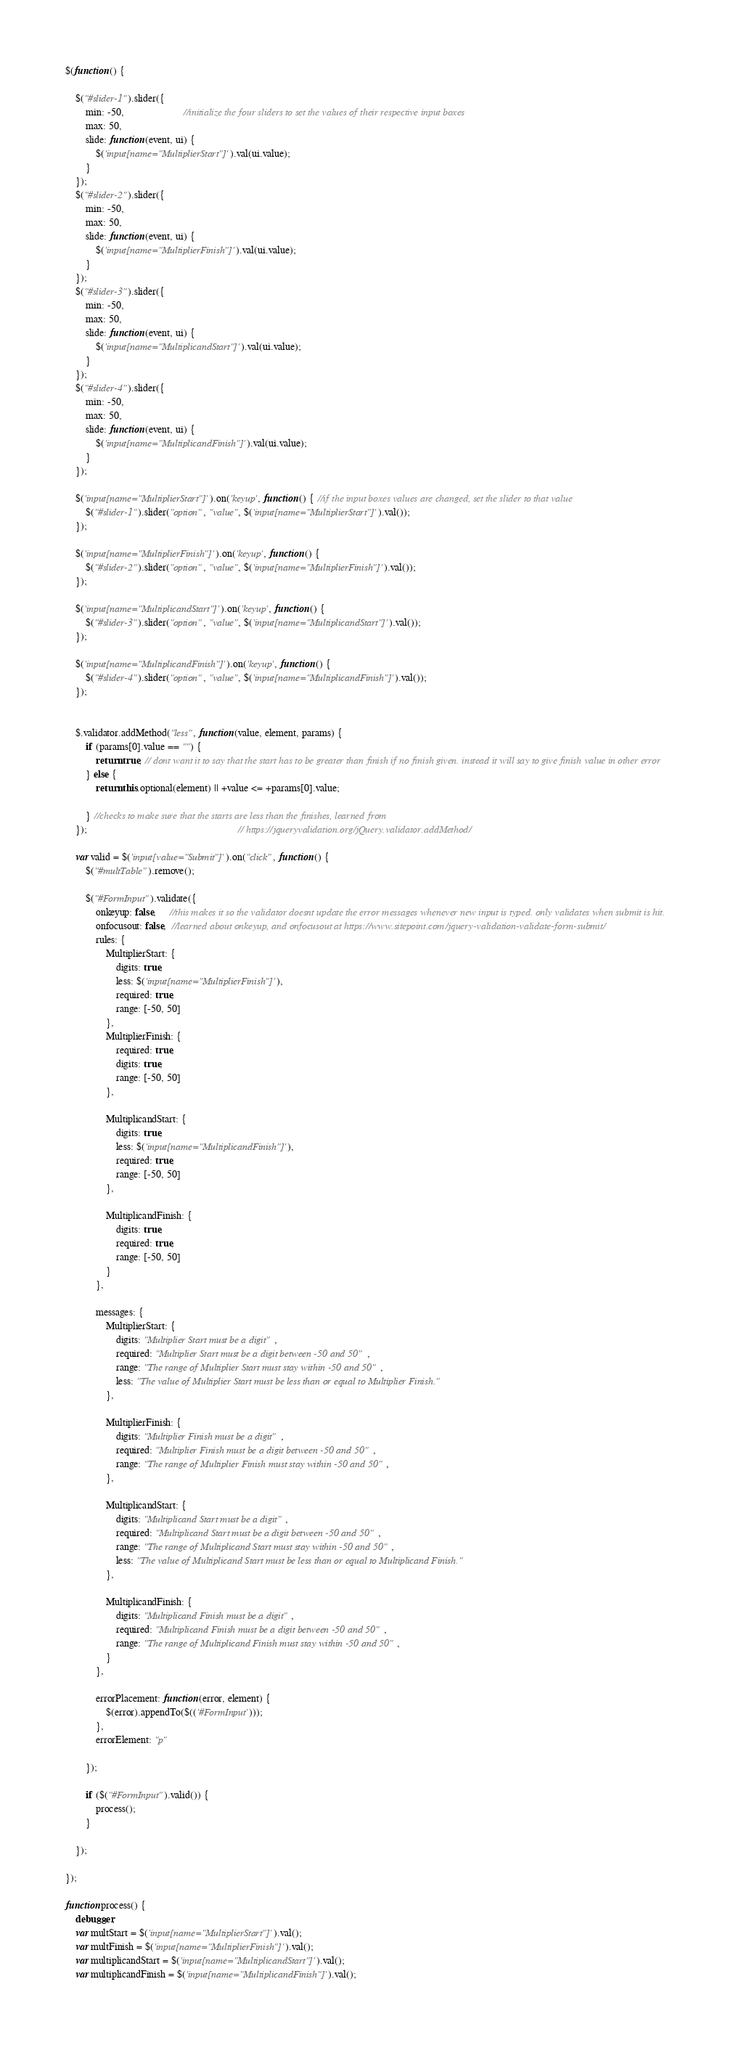Convert code to text. <code><loc_0><loc_0><loc_500><loc_500><_JavaScript_>$(function () {

    $("#slider-1").slider({
        min: -50,                       //initialize the four sliders to set the values of their respective input boxes
        max: 50,
        slide: function (event, ui) {
            $('input[name="MultiplierStart"]').val(ui.value);
        }
    });
    $("#slider-2").slider({
        min: -50,
        max: 50,
        slide: function (event, ui) {
            $('input[name="MultiplierFinish"]').val(ui.value);
        }
    });
    $("#slider-3").slider({
        min: -50,
        max: 50,
        slide: function (event, ui) {
            $('input[name="MultiplicandStart"]').val(ui.value);
        }
    });
    $("#slider-4").slider({
        min: -50,
        max: 50,
        slide: function (event, ui) {
            $('input[name="MultiplicandFinish"]').val(ui.value);
        }
    });

    $('input[name="MultiplierStart"]').on('keyup', function () { //if the input boxes values are changed, set the slider to that value
        $("#slider-1").slider("option", "value", $('input[name="MultiplierStart"]').val());
    });

    $('input[name="MultiplierFinish"]').on('keyup', function () { 
        $("#slider-2").slider("option", "value", $('input[name="MultiplierFinish"]').val());
    });

    $('input[name="MultiplicandStart"]').on('keyup', function () { 
        $("#slider-3").slider("option", "value", $('input[name="MultiplicandStart"]').val());
    });

    $('input[name="MultiplicandFinish"]').on('keyup', function () { 
        $("#slider-4").slider("option", "value", $('input[name="MultiplicandFinish"]').val());
    });
    

    $.validator.addMethod("less", function (value, element, params) {
        if (params[0].value == "") {
            return true; // dont want it to say that the start has to be greater than finish if no finish given. instead it will say to give finish value in other error
        } else {
            return this.optional(element) || +value <= +params[0].value;
            
        } //checks to make sure that the starts are less than the finishes, learned from
    });                                                           // https://jqueryvalidation.org/jQuery.validator.addMethod/

    var valid = $('input[value="Submit"]').on("click", function () {
        $("#multTable").remove();

        $("#FormInput").validate({
            onkeyup: false,     //this makes it so the validator doesnt update the error messages whenever new input is typed. only validates when submit is hit.
            onfocusout: false,  //learned about onkeyup, and onfocusout at https://www.sitepoint.com/jquery-validation-validate-form-submit/
            rules: {
                MultiplierStart: {
                    digits: true,
                    less: $('input[name="MultiplierFinish"]'),
                    required: true,
                    range: [-50, 50]
                },
                MultiplierFinish: {
                    required: true,
                    digits: true,
                    range: [-50, 50]
                },

                MultiplicandStart: {
                    digits: true,
                    less: $('input[name="MultiplicandFinish"]'),
                    required: true,
                    range: [-50, 50]
                },

                MultiplicandFinish: {
                    digits: true,
                    required: true,
                    range: [-50, 50]
                }
            },

            messages: {
                MultiplierStart: {
                    digits: "Multiplier Start must be a digit",
                    required: "Multiplier Start must be a digit between -50 and 50",
                    range: "The range of Multiplier Start must stay within -50 and 50",
                    less: "The value of Multiplier Start must be less than or equal to Multiplier Finish."
                },

                MultiplierFinish: {
                    digits: "Multiplier Finish must be a digit",
                    required: "Multiplier Finish must be a digit between -50 and 50",
                    range: "The range of Multiplier Finish must stay within -50 and 50",
                },

                MultiplicandStart: {
                    digits: "Multiplicand Start must be a digit",
                    required: "Multiplicand Start must be a digit between -50 and 50",
                    range: "The range of Multiplicand Start must stay within -50 and 50",
                    less: "The value of Multiplicand Start must be less than or equal to Multiplicand Finish."
                },

                MultiplicandFinish: {
                    digits: "Multiplicand Finish must be a digit",
                    required: "Multiplicand Finish must be a digit between -50 and 50",
                    range: "The range of Multiplicand Finish must stay within -50 and 50",
                }
            },
            
            errorPlacement: function (error, element) {
                $(error).appendTo($(('#FormInput')));
            },
            errorElement: "p"
            
        });
    
        if ($("#FormInput").valid()) {
            process();
        }
    
    });

});

function process() {
    debugger;
    var multStart = $('input[name="MultiplierStart"]').val();
    var multFinish = $('input[name="MultiplierFinish"]').val();
    var multiplicandStart = $('input[name="MultiplicandStart"]').val();
    var multiplicandFinish = $('input[name="MultiplicandFinish"]').val();
</code> 